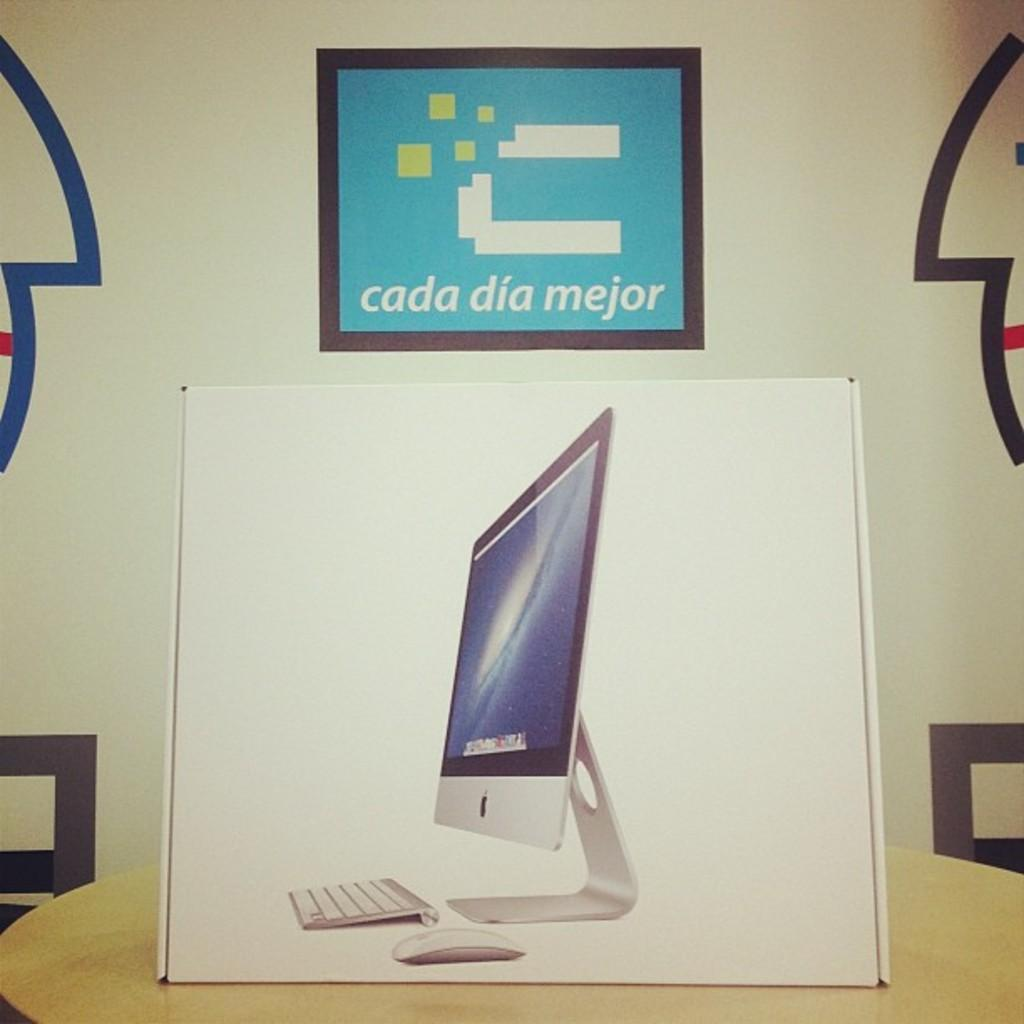<image>
Render a clear and concise summary of the photo. An Apple IMAC box sits on a table with sign above it that reads cada dia mejor 